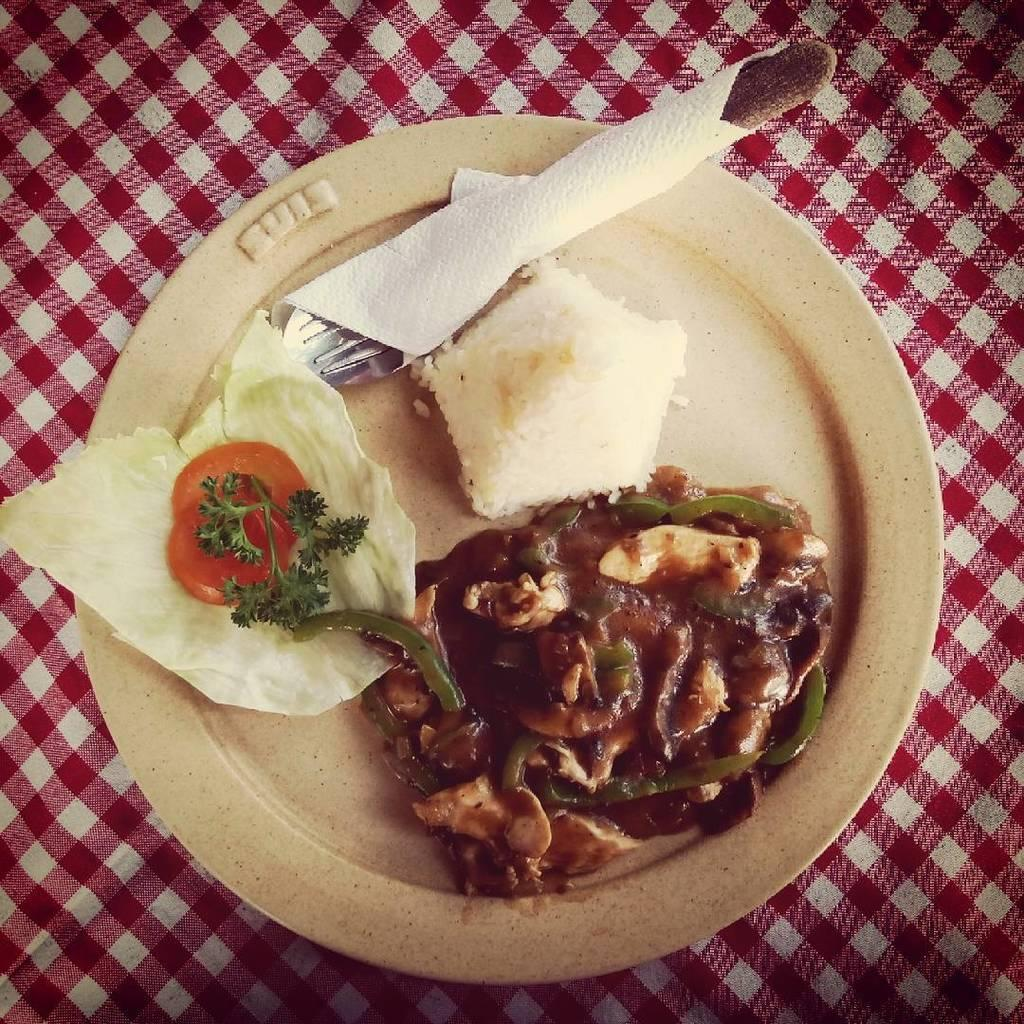What is the main object in the center of the image? There is a plate in the center of the image. What is on the plate? The plate contains a food item. What utensil is on the plate? There is a fork on the plate. What item is used for cleaning or wiping on the plate? There is a tissue on the plate. What type of hole can be seen in the plate in the image? There is no hole present in the plate in the image. Can you tell me how many cribs are visible in the image? There are no cribs present in the image. 